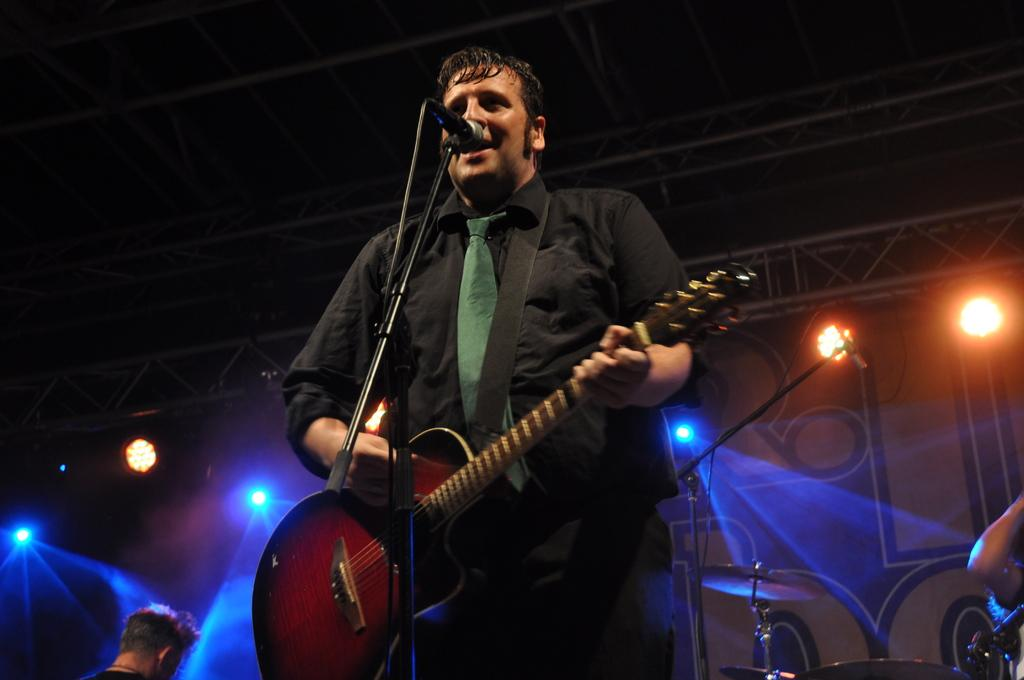What is the man in the image doing? The man is playing a guitar and singing. How is the man amplifying his voice in the image? The man is using a microphone. What type of chain is the man wearing around his feet in the image? There is no chain visible around the man's feet in the image. 